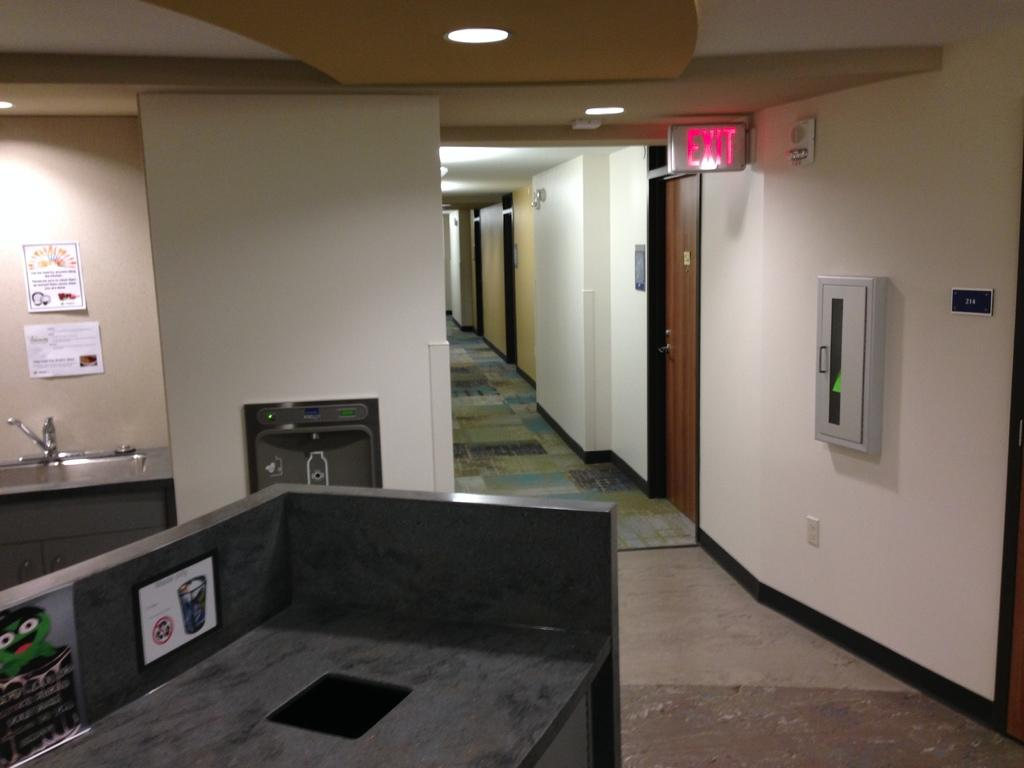<image>
Provide a brief description of the given image. Office with a sign on the ceiling that says EXIT. 